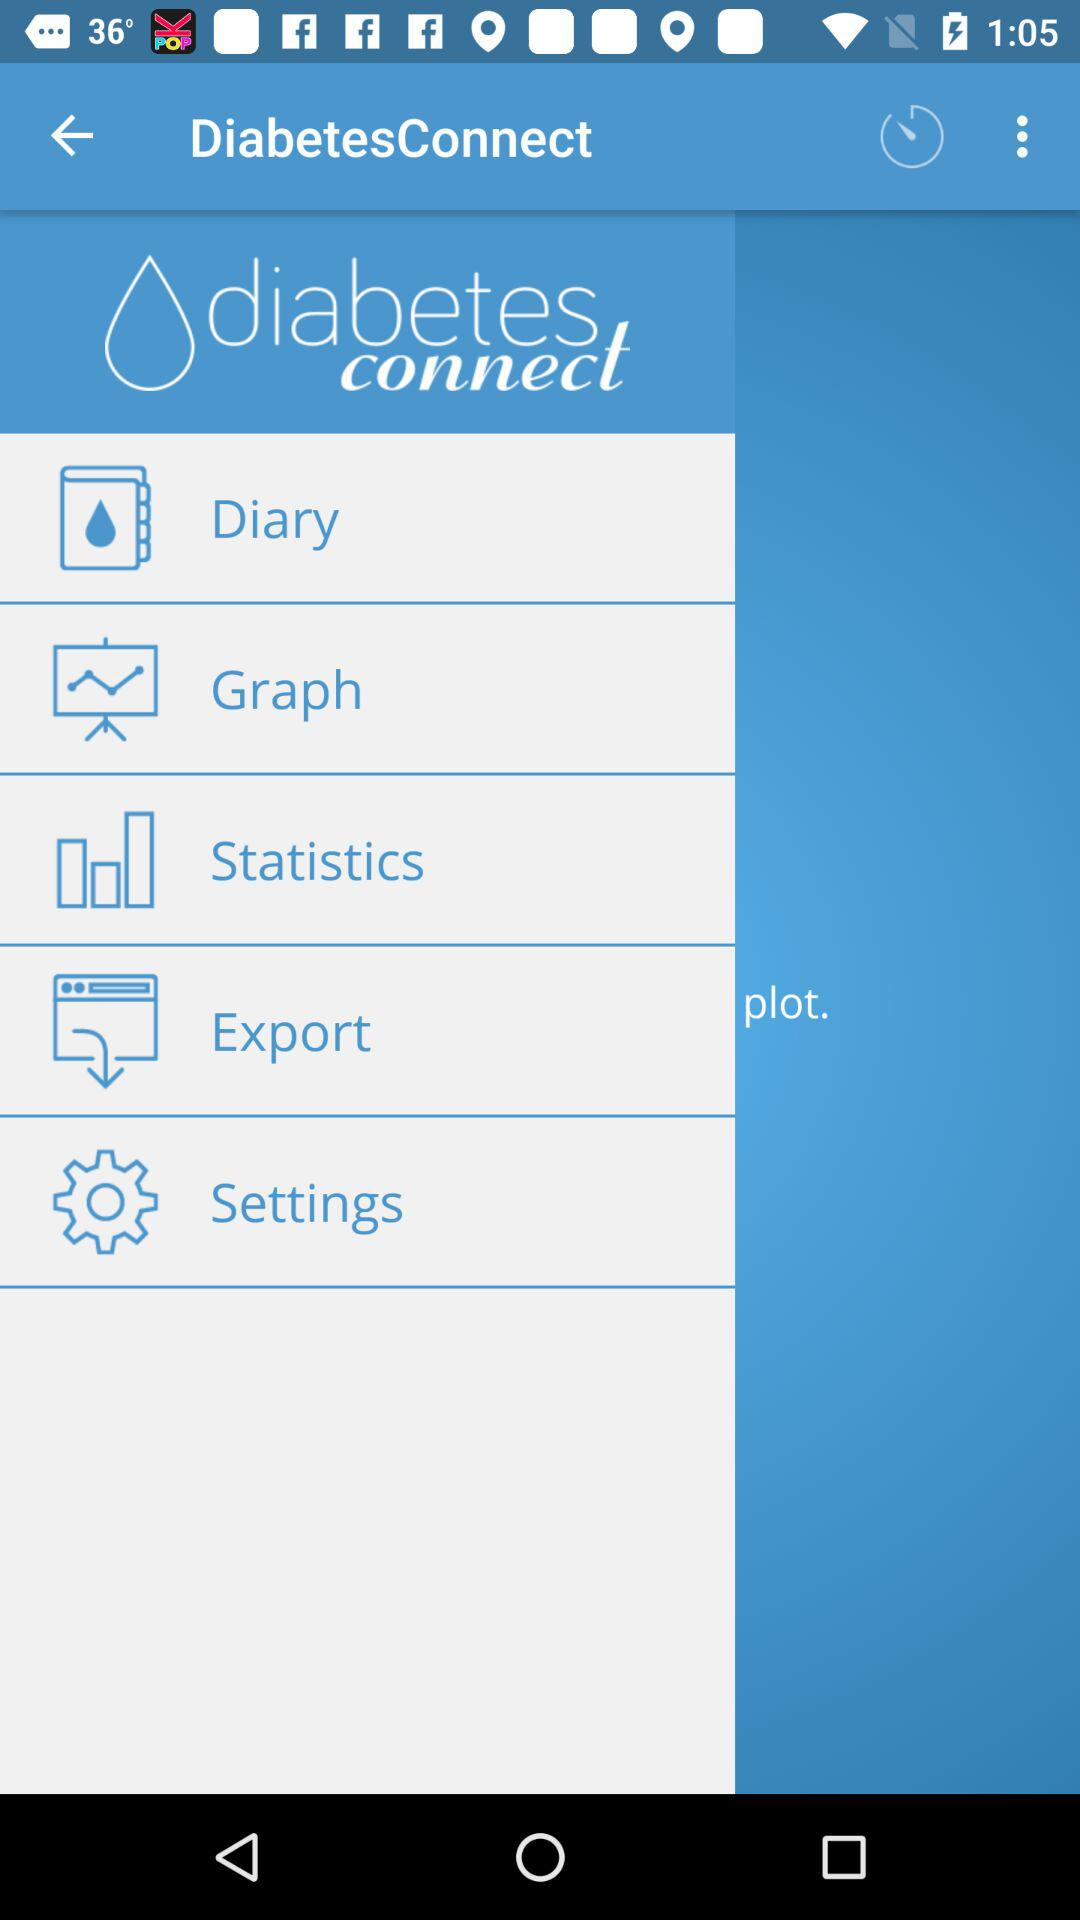What is the app name? The app name is "DiabetesConnect". 